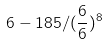<formula> <loc_0><loc_0><loc_500><loc_500>6 - 1 8 5 / ( \frac { 6 } { 6 } ) ^ { 8 }</formula> 